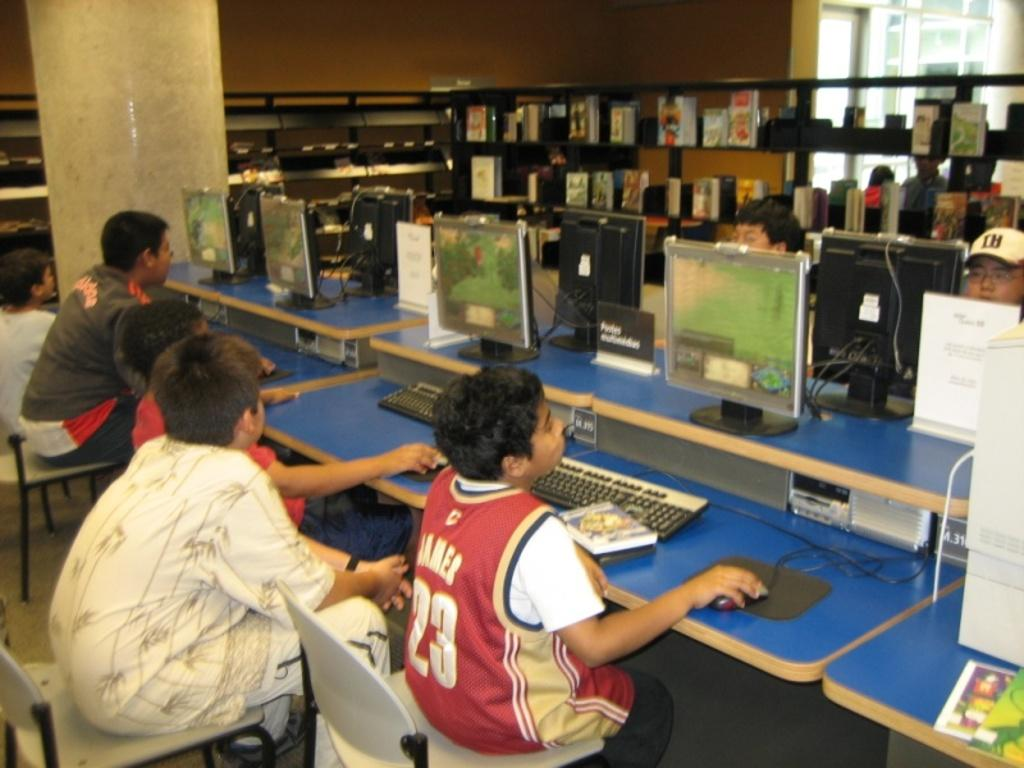<image>
Offer a succinct explanation of the picture presented. A young boy in front of a computer wearing a jersey with number 23 and James on it 